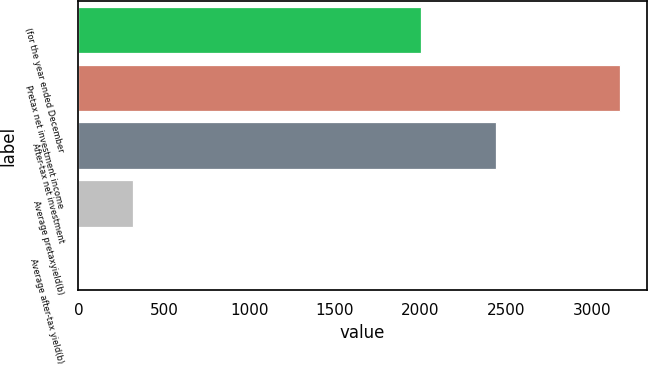<chart> <loc_0><loc_0><loc_500><loc_500><bar_chart><fcel>(for the year ended December<fcel>Pretax net investment income<fcel>After-tax net investment<fcel>Average pretaxyield(b)<fcel>Average after-tax yield(b)<nl><fcel>2005<fcel>3165<fcel>2438<fcel>319.83<fcel>3.7<nl></chart> 